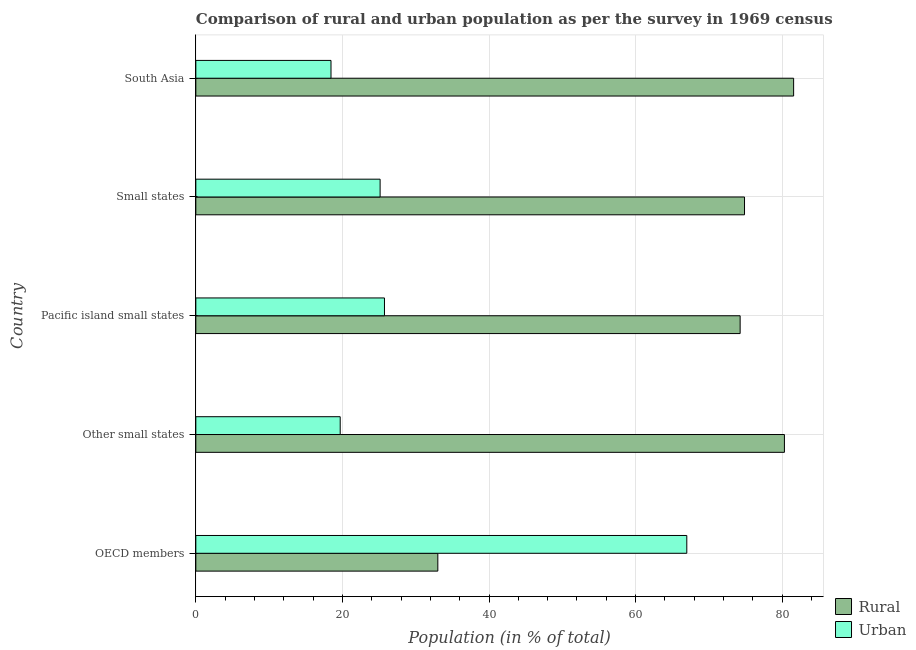How many groups of bars are there?
Keep it short and to the point. 5. How many bars are there on the 3rd tick from the bottom?
Your answer should be very brief. 2. What is the urban population in South Asia?
Your answer should be compact. 18.44. Across all countries, what is the maximum rural population?
Provide a succinct answer. 81.56. Across all countries, what is the minimum urban population?
Keep it short and to the point. 18.44. What is the total urban population in the graph?
Make the answer very short. 156. What is the difference between the urban population in OECD members and the rural population in Other small states?
Make the answer very short. -13.32. What is the average rural population per country?
Give a very brief answer. 68.8. What is the difference between the rural population and urban population in OECD members?
Offer a terse response. -33.97. In how many countries, is the rural population greater than 60 %?
Offer a very short reply. 4. What is the ratio of the rural population in Pacific island small states to that in Small states?
Provide a succinct answer. 0.99. Is the urban population in OECD members less than that in South Asia?
Give a very brief answer. No. Is the difference between the urban population in Small states and South Asia greater than the difference between the rural population in Small states and South Asia?
Your response must be concise. Yes. What is the difference between the highest and the second highest rural population?
Provide a short and direct response. 1.25. What is the difference between the highest and the lowest rural population?
Ensure brevity in your answer.  48.54. In how many countries, is the rural population greater than the average rural population taken over all countries?
Your response must be concise. 4. Is the sum of the urban population in Other small states and Pacific island small states greater than the maximum rural population across all countries?
Ensure brevity in your answer.  No. What does the 1st bar from the top in Pacific island small states represents?
Ensure brevity in your answer.  Urban. What does the 1st bar from the bottom in Small states represents?
Ensure brevity in your answer.  Rural. Are all the bars in the graph horizontal?
Ensure brevity in your answer.  Yes. How many countries are there in the graph?
Your response must be concise. 5. What is the difference between two consecutive major ticks on the X-axis?
Your answer should be very brief. 20. Does the graph contain grids?
Keep it short and to the point. Yes. Where does the legend appear in the graph?
Offer a very short reply. Bottom right. What is the title of the graph?
Your response must be concise. Comparison of rural and urban population as per the survey in 1969 census. What is the label or title of the X-axis?
Your answer should be compact. Population (in % of total). What is the label or title of the Y-axis?
Ensure brevity in your answer.  Country. What is the Population (in % of total) in Rural in OECD members?
Provide a short and direct response. 33.02. What is the Population (in % of total) of Urban in OECD members?
Keep it short and to the point. 66.98. What is the Population (in % of total) of Rural in Other small states?
Your answer should be very brief. 80.3. What is the Population (in % of total) of Urban in Other small states?
Ensure brevity in your answer.  19.7. What is the Population (in % of total) in Rural in Pacific island small states?
Make the answer very short. 74.26. What is the Population (in % of total) in Urban in Pacific island small states?
Ensure brevity in your answer.  25.74. What is the Population (in % of total) in Rural in Small states?
Keep it short and to the point. 74.86. What is the Population (in % of total) in Urban in Small states?
Provide a short and direct response. 25.14. What is the Population (in % of total) of Rural in South Asia?
Offer a terse response. 81.56. What is the Population (in % of total) in Urban in South Asia?
Your answer should be very brief. 18.44. Across all countries, what is the maximum Population (in % of total) of Rural?
Make the answer very short. 81.56. Across all countries, what is the maximum Population (in % of total) of Urban?
Ensure brevity in your answer.  66.98. Across all countries, what is the minimum Population (in % of total) of Rural?
Your answer should be compact. 33.02. Across all countries, what is the minimum Population (in % of total) of Urban?
Offer a terse response. 18.44. What is the total Population (in % of total) in Rural in the graph?
Provide a succinct answer. 344. What is the total Population (in % of total) in Urban in the graph?
Provide a short and direct response. 156. What is the difference between the Population (in % of total) of Rural in OECD members and that in Other small states?
Your answer should be very brief. -47.29. What is the difference between the Population (in % of total) in Urban in OECD members and that in Other small states?
Provide a short and direct response. 47.29. What is the difference between the Population (in % of total) of Rural in OECD members and that in Pacific island small states?
Make the answer very short. -41.25. What is the difference between the Population (in % of total) of Urban in OECD members and that in Pacific island small states?
Offer a very short reply. 41.25. What is the difference between the Population (in % of total) of Rural in OECD members and that in Small states?
Make the answer very short. -41.84. What is the difference between the Population (in % of total) of Urban in OECD members and that in Small states?
Your answer should be very brief. 41.84. What is the difference between the Population (in % of total) in Rural in OECD members and that in South Asia?
Your response must be concise. -48.54. What is the difference between the Population (in % of total) in Urban in OECD members and that in South Asia?
Ensure brevity in your answer.  48.54. What is the difference between the Population (in % of total) in Rural in Other small states and that in Pacific island small states?
Keep it short and to the point. 6.04. What is the difference between the Population (in % of total) in Urban in Other small states and that in Pacific island small states?
Your answer should be very brief. -6.04. What is the difference between the Population (in % of total) of Rural in Other small states and that in Small states?
Offer a very short reply. 5.45. What is the difference between the Population (in % of total) of Urban in Other small states and that in Small states?
Keep it short and to the point. -5.45. What is the difference between the Population (in % of total) in Rural in Other small states and that in South Asia?
Provide a short and direct response. -1.25. What is the difference between the Population (in % of total) of Urban in Other small states and that in South Asia?
Offer a very short reply. 1.25. What is the difference between the Population (in % of total) of Rural in Pacific island small states and that in Small states?
Ensure brevity in your answer.  -0.6. What is the difference between the Population (in % of total) of Urban in Pacific island small states and that in Small states?
Provide a short and direct response. 0.6. What is the difference between the Population (in % of total) of Rural in Pacific island small states and that in South Asia?
Provide a short and direct response. -7.3. What is the difference between the Population (in % of total) of Urban in Pacific island small states and that in South Asia?
Offer a terse response. 7.3. What is the difference between the Population (in % of total) in Rural in Small states and that in South Asia?
Ensure brevity in your answer.  -6.7. What is the difference between the Population (in % of total) in Urban in Small states and that in South Asia?
Make the answer very short. 6.7. What is the difference between the Population (in % of total) of Rural in OECD members and the Population (in % of total) of Urban in Other small states?
Give a very brief answer. 13.32. What is the difference between the Population (in % of total) in Rural in OECD members and the Population (in % of total) in Urban in Pacific island small states?
Offer a terse response. 7.28. What is the difference between the Population (in % of total) of Rural in OECD members and the Population (in % of total) of Urban in Small states?
Provide a short and direct response. 7.87. What is the difference between the Population (in % of total) of Rural in OECD members and the Population (in % of total) of Urban in South Asia?
Offer a terse response. 14.57. What is the difference between the Population (in % of total) in Rural in Other small states and the Population (in % of total) in Urban in Pacific island small states?
Provide a short and direct response. 54.57. What is the difference between the Population (in % of total) in Rural in Other small states and the Population (in % of total) in Urban in Small states?
Your answer should be compact. 55.16. What is the difference between the Population (in % of total) of Rural in Other small states and the Population (in % of total) of Urban in South Asia?
Your response must be concise. 61.86. What is the difference between the Population (in % of total) in Rural in Pacific island small states and the Population (in % of total) in Urban in Small states?
Your response must be concise. 49.12. What is the difference between the Population (in % of total) of Rural in Pacific island small states and the Population (in % of total) of Urban in South Asia?
Offer a very short reply. 55.82. What is the difference between the Population (in % of total) of Rural in Small states and the Population (in % of total) of Urban in South Asia?
Ensure brevity in your answer.  56.42. What is the average Population (in % of total) in Rural per country?
Your answer should be compact. 68.8. What is the average Population (in % of total) of Urban per country?
Make the answer very short. 31.2. What is the difference between the Population (in % of total) in Rural and Population (in % of total) in Urban in OECD members?
Your answer should be compact. -33.97. What is the difference between the Population (in % of total) of Rural and Population (in % of total) of Urban in Other small states?
Your answer should be very brief. 60.61. What is the difference between the Population (in % of total) of Rural and Population (in % of total) of Urban in Pacific island small states?
Your answer should be very brief. 48.52. What is the difference between the Population (in % of total) of Rural and Population (in % of total) of Urban in Small states?
Make the answer very short. 49.72. What is the difference between the Population (in % of total) in Rural and Population (in % of total) in Urban in South Asia?
Give a very brief answer. 63.12. What is the ratio of the Population (in % of total) in Rural in OECD members to that in Other small states?
Provide a succinct answer. 0.41. What is the ratio of the Population (in % of total) in Urban in OECD members to that in Other small states?
Ensure brevity in your answer.  3.4. What is the ratio of the Population (in % of total) of Rural in OECD members to that in Pacific island small states?
Offer a terse response. 0.44. What is the ratio of the Population (in % of total) in Urban in OECD members to that in Pacific island small states?
Your answer should be very brief. 2.6. What is the ratio of the Population (in % of total) of Rural in OECD members to that in Small states?
Provide a succinct answer. 0.44. What is the ratio of the Population (in % of total) of Urban in OECD members to that in Small states?
Offer a very short reply. 2.66. What is the ratio of the Population (in % of total) in Rural in OECD members to that in South Asia?
Your answer should be compact. 0.4. What is the ratio of the Population (in % of total) of Urban in OECD members to that in South Asia?
Provide a succinct answer. 3.63. What is the ratio of the Population (in % of total) in Rural in Other small states to that in Pacific island small states?
Ensure brevity in your answer.  1.08. What is the ratio of the Population (in % of total) in Urban in Other small states to that in Pacific island small states?
Keep it short and to the point. 0.77. What is the ratio of the Population (in % of total) in Rural in Other small states to that in Small states?
Make the answer very short. 1.07. What is the ratio of the Population (in % of total) of Urban in Other small states to that in Small states?
Make the answer very short. 0.78. What is the ratio of the Population (in % of total) of Rural in Other small states to that in South Asia?
Keep it short and to the point. 0.98. What is the ratio of the Population (in % of total) in Urban in Other small states to that in South Asia?
Your answer should be very brief. 1.07. What is the ratio of the Population (in % of total) of Urban in Pacific island small states to that in Small states?
Offer a terse response. 1.02. What is the ratio of the Population (in % of total) in Rural in Pacific island small states to that in South Asia?
Provide a succinct answer. 0.91. What is the ratio of the Population (in % of total) in Urban in Pacific island small states to that in South Asia?
Your response must be concise. 1.4. What is the ratio of the Population (in % of total) in Rural in Small states to that in South Asia?
Your response must be concise. 0.92. What is the ratio of the Population (in % of total) in Urban in Small states to that in South Asia?
Your answer should be very brief. 1.36. What is the difference between the highest and the second highest Population (in % of total) of Rural?
Offer a terse response. 1.25. What is the difference between the highest and the second highest Population (in % of total) in Urban?
Provide a succinct answer. 41.25. What is the difference between the highest and the lowest Population (in % of total) in Rural?
Your response must be concise. 48.54. What is the difference between the highest and the lowest Population (in % of total) of Urban?
Keep it short and to the point. 48.54. 